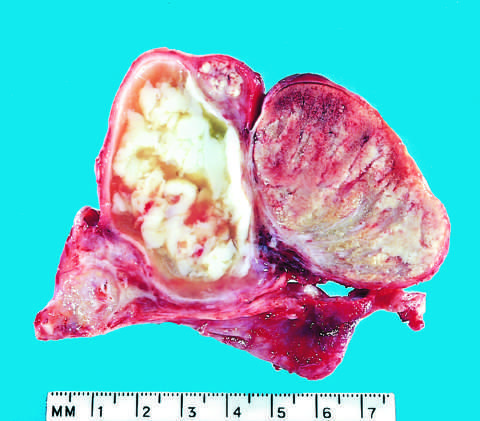what is involved by an abscess?
Answer the question using a single word or phrase. The epididymis 